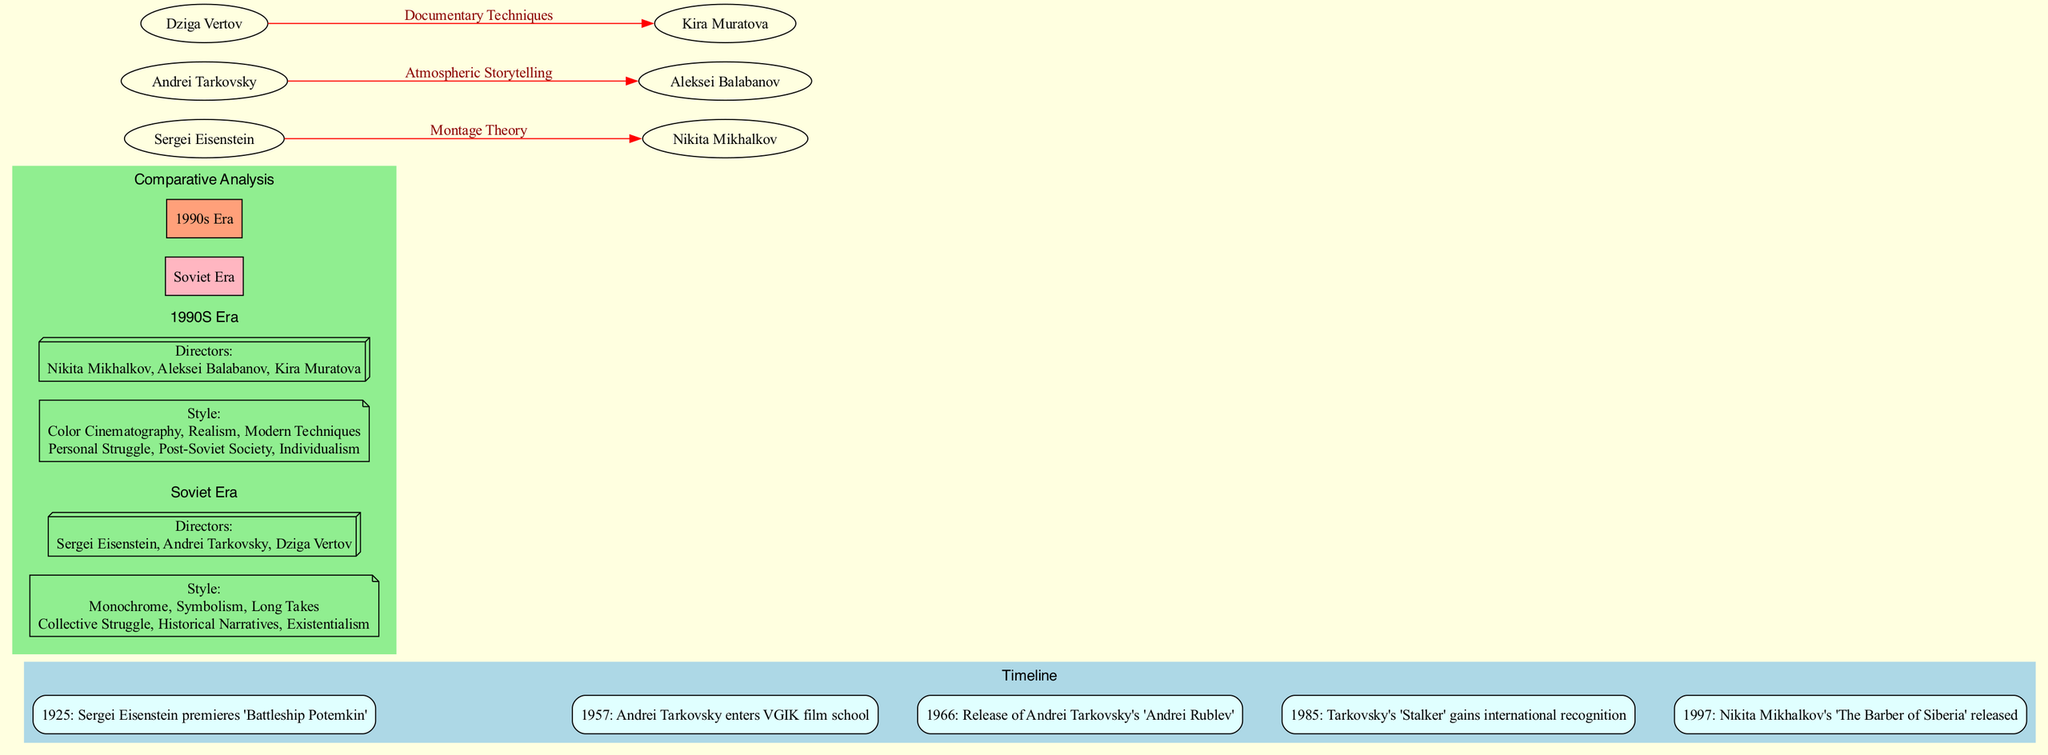What year did Sergei Eisenstein premiere 'Battleship Potemkin'? According to the timeline in the diagram, the milestone for the premiere of 'Battleship Potemkin' is marked in the year 1925.
Answer: 1925 Who directed 'The Barber of Siberia'? The diagram lists Nikita Mikhalkov as the director of 'The Barber of Siberia', which is highlighted in the 1997 milestone.
Answer: Nikita Mikhalkov How many major directors are associated with the Soviet era? The diagram lists three major directors in the Soviet era: Sergei Eisenstein, Andrei Tarkovsky, and Dziga Vertov. Thus, the total count is three.
Answer: 3 Which director's work is linked to atmospheric storytelling? The influences section connects Andrei Tarkovsky to Aleksei Balabanov through the element of atmospheric storytelling.
Answer: Aleksei Balabanov In which year did Andrei Tarkovsky release 'Andrei Rublev'? The diagram indicates that the release of 'Andrei Rublev' occurred in 1966.
Answer: 1966 What are the two key themes in 1990s Russian cinema displayed in the diagram? The comparative analysis of the 1990s era lists "Personal Struggle" and "Post-Soviet Society" as part of its thematic focus.
Answer: Personal Struggle, Post-Soviet Society How did Dziga Vertov influence Kira Muratova? The influence section shows that Dziga Vertov influenced Kira Muratova by introducing documentary techniques into her work.
Answer: Documentary Techniques What style of cinematography became prominent in the 1990s era? According to the comparative analysis, color cinematography is listed as a prominent style in the 1990s era.
Answer: Color Cinematography Which event signifies the international recognition of Tarkovsky's work? The diagram highlights that Tarkovsky's 'Stalker' gaining international recognition in 1985 is the significant event marked on the timeline.
Answer: Tarkovsky's 'Stalker' gains international recognition What connects Eisenstein and Mikhalkov in the influence section? The diagram explicitly links Eisenstein to Mikhalkov through the concept of montage theory, as shown in the influences section.
Answer: Montage Theory 